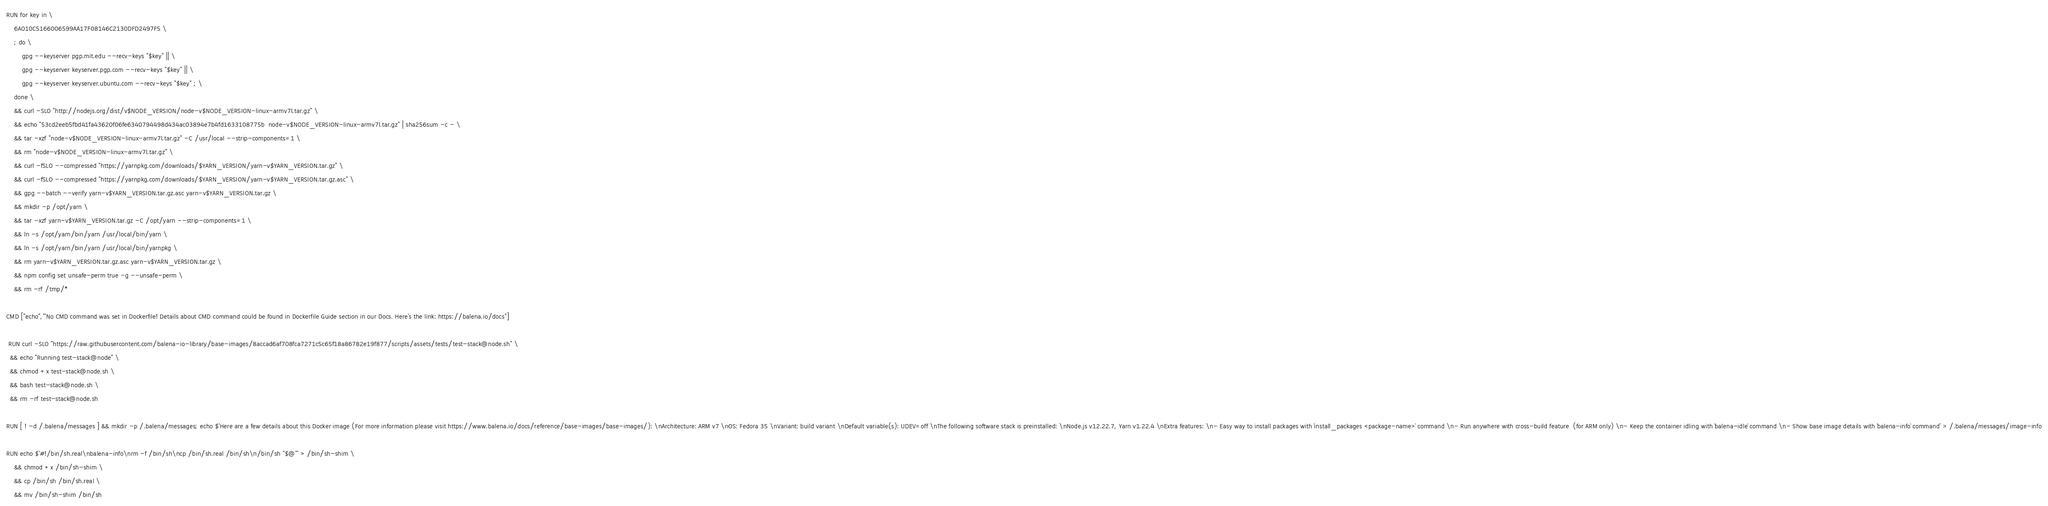<code> <loc_0><loc_0><loc_500><loc_500><_Dockerfile_>
RUN for key in \
	6A010C5166006599AA17F08146C2130DFD2497F5 \
	; do \
		gpg --keyserver pgp.mit.edu --recv-keys "$key" || \
		gpg --keyserver keyserver.pgp.com --recv-keys "$key" || \
		gpg --keyserver keyserver.ubuntu.com --recv-keys "$key" ; \
	done \
	&& curl -SLO "http://nodejs.org/dist/v$NODE_VERSION/node-v$NODE_VERSION-linux-armv7l.tar.gz" \
	&& echo "53cd2eeb5fbd41fa43620f06fe6340794498d434ac03894e7b4fd1633108775b  node-v$NODE_VERSION-linux-armv7l.tar.gz" | sha256sum -c - \
	&& tar -xzf "node-v$NODE_VERSION-linux-armv7l.tar.gz" -C /usr/local --strip-components=1 \
	&& rm "node-v$NODE_VERSION-linux-armv7l.tar.gz" \
	&& curl -fSLO --compressed "https://yarnpkg.com/downloads/$YARN_VERSION/yarn-v$YARN_VERSION.tar.gz" \
	&& curl -fSLO --compressed "https://yarnpkg.com/downloads/$YARN_VERSION/yarn-v$YARN_VERSION.tar.gz.asc" \
	&& gpg --batch --verify yarn-v$YARN_VERSION.tar.gz.asc yarn-v$YARN_VERSION.tar.gz \
	&& mkdir -p /opt/yarn \
	&& tar -xzf yarn-v$YARN_VERSION.tar.gz -C /opt/yarn --strip-components=1 \
	&& ln -s /opt/yarn/bin/yarn /usr/local/bin/yarn \
	&& ln -s /opt/yarn/bin/yarn /usr/local/bin/yarnpkg \
	&& rm yarn-v$YARN_VERSION.tar.gz.asc yarn-v$YARN_VERSION.tar.gz \
	&& npm config set unsafe-perm true -g --unsafe-perm \
	&& rm -rf /tmp/*

CMD ["echo","'No CMD command was set in Dockerfile! Details about CMD command could be found in Dockerfile Guide section in our Docs. Here's the link: https://balena.io/docs"]

 RUN curl -SLO "https://raw.githubusercontent.com/balena-io-library/base-images/8accad6af708fca7271c5c65f18a86782e19f877/scripts/assets/tests/test-stack@node.sh" \
  && echo "Running test-stack@node" \
  && chmod +x test-stack@node.sh \
  && bash test-stack@node.sh \
  && rm -rf test-stack@node.sh 

RUN [ ! -d /.balena/messages ] && mkdir -p /.balena/messages; echo $'Here are a few details about this Docker image (For more information please visit https://www.balena.io/docs/reference/base-images/base-images/): \nArchitecture: ARM v7 \nOS: Fedora 35 \nVariant: build variant \nDefault variable(s): UDEV=off \nThe following software stack is preinstalled: \nNode.js v12.22.7, Yarn v1.22.4 \nExtra features: \n- Easy way to install packages with `install_packages <package-name>` command \n- Run anywhere with cross-build feature  (for ARM only) \n- Keep the container idling with `balena-idle` command \n- Show base image details with `balena-info` command' > /.balena/messages/image-info

RUN echo $'#!/bin/sh.real\nbalena-info\nrm -f /bin/sh\ncp /bin/sh.real /bin/sh\n/bin/sh "$@"' > /bin/sh-shim \
	&& chmod +x /bin/sh-shim \
	&& cp /bin/sh /bin/sh.real \
	&& mv /bin/sh-shim /bin/sh</code> 